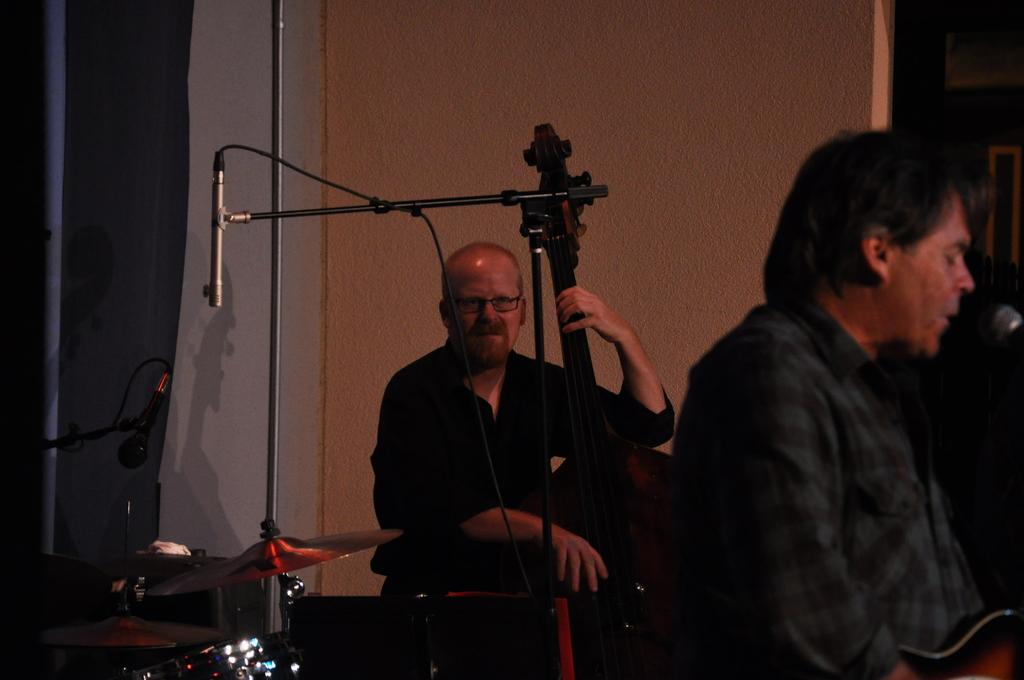How many people are in the image? There are two persons in the image. What are the persons doing in the image? The persons are sitting and holding musical instruments. What equipment is present in the image for amplifying sound? There are microphones in the image. What type of percussion instrument can be seen in the image? There are cymbals with cymbal stands in the image. What is visible in the background of the image? There is a wall in the background of the image. What advice are the chickens giving to the musicians in the image? There are no chickens present in the image, so they cannot give any advice to the musicians. 